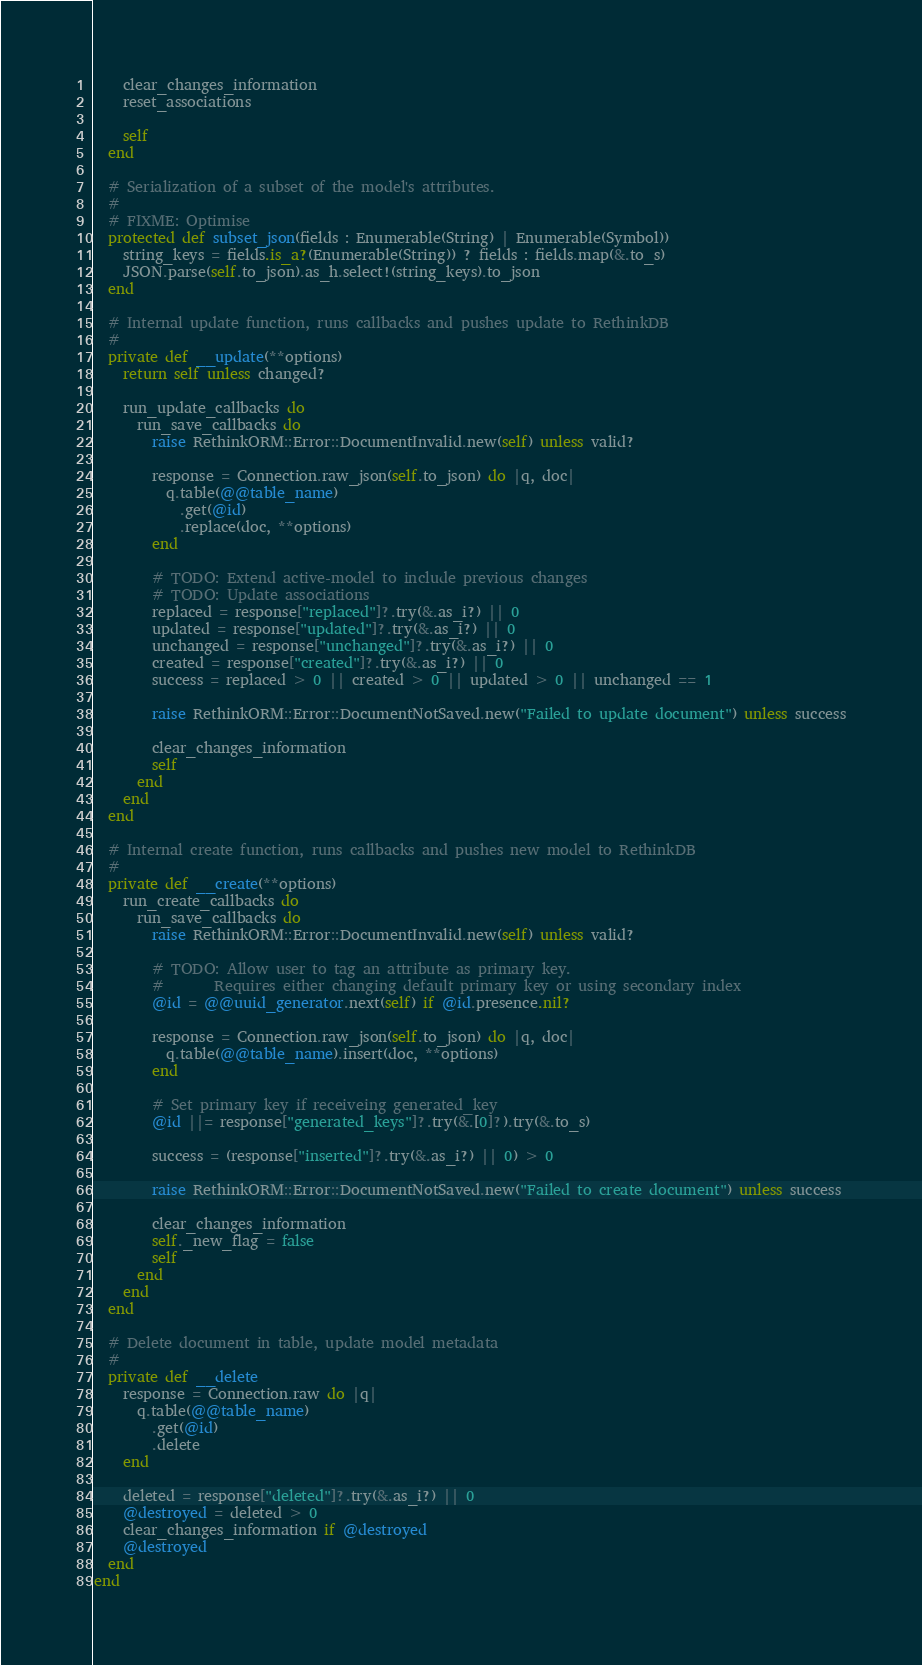Convert code to text. <code><loc_0><loc_0><loc_500><loc_500><_Crystal_>    clear_changes_information
    reset_associations

    self
  end

  # Serialization of a subset of the model's attributes.
  #
  # FIXME: Optimise
  protected def subset_json(fields : Enumerable(String) | Enumerable(Symbol))
    string_keys = fields.is_a?(Enumerable(String)) ? fields : fields.map(&.to_s)
    JSON.parse(self.to_json).as_h.select!(string_keys).to_json
  end

  # Internal update function, runs callbacks and pushes update to RethinkDB
  #
  private def __update(**options)
    return self unless changed?

    run_update_callbacks do
      run_save_callbacks do
        raise RethinkORM::Error::DocumentInvalid.new(self) unless valid?

        response = Connection.raw_json(self.to_json) do |q, doc|
          q.table(@@table_name)
            .get(@id)
            .replace(doc, **options)
        end

        # TODO: Extend active-model to include previous changes
        # TODO: Update associations
        replaced = response["replaced"]?.try(&.as_i?) || 0
        updated = response["updated"]?.try(&.as_i?) || 0
        unchanged = response["unchanged"]?.try(&.as_i?) || 0
        created = response["created"]?.try(&.as_i?) || 0
        success = replaced > 0 || created > 0 || updated > 0 || unchanged == 1

        raise RethinkORM::Error::DocumentNotSaved.new("Failed to update document") unless success

        clear_changes_information
        self
      end
    end
  end

  # Internal create function, runs callbacks and pushes new model to RethinkDB
  #
  private def __create(**options)
    run_create_callbacks do
      run_save_callbacks do
        raise RethinkORM::Error::DocumentInvalid.new(self) unless valid?

        # TODO: Allow user to tag an attribute as primary key.
        #       Requires either changing default primary key or using secondary index
        @id = @@uuid_generator.next(self) if @id.presence.nil?

        response = Connection.raw_json(self.to_json) do |q, doc|
          q.table(@@table_name).insert(doc, **options)
        end

        # Set primary key if receiveing generated_key
        @id ||= response["generated_keys"]?.try(&.[0]?).try(&.to_s)

        success = (response["inserted"]?.try(&.as_i?) || 0) > 0

        raise RethinkORM::Error::DocumentNotSaved.new("Failed to create document") unless success

        clear_changes_information
        self._new_flag = false
        self
      end
    end
  end

  # Delete document in table, update model metadata
  #
  private def __delete
    response = Connection.raw do |q|
      q.table(@@table_name)
        .get(@id)
        .delete
    end

    deleted = response["deleted"]?.try(&.as_i?) || 0
    @destroyed = deleted > 0
    clear_changes_information if @destroyed
    @destroyed
  end
end
</code> 